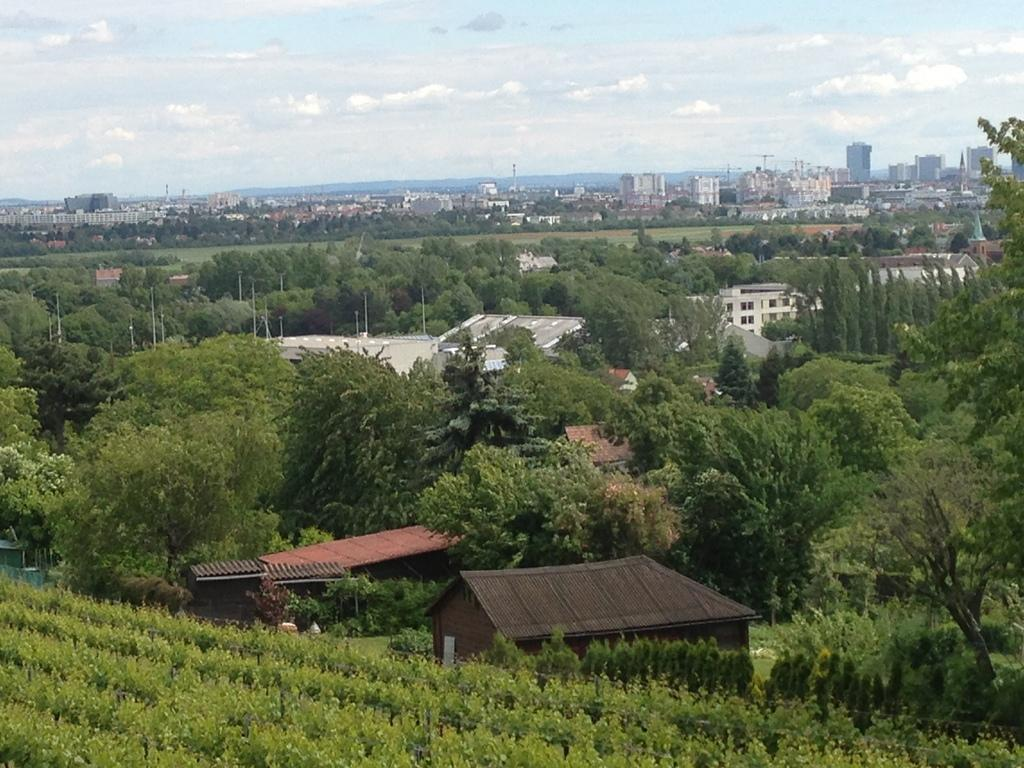What type of structures can be seen in the image? There are buildings in the image. What natural elements are present in the image? There are trees in the image. What else can be seen in the image besides buildings and trees? There are poles in the image. What is visible in the background of the image? The sky is visible in the background of the image. Where is the frog sitting in the image? There is no frog present in the image. What color is the lipstick on the person's lips in the image? There are no people or lipstick visible in the image. 